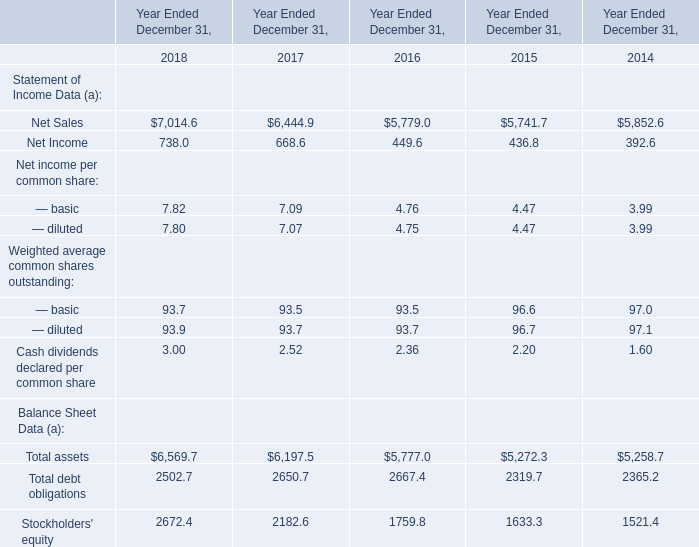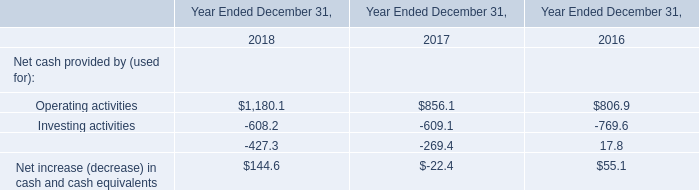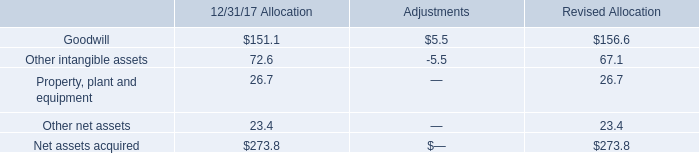What is the average value of Net Income in Table 0 and Operating activities in Table 1 in 2016? 
Computations: ((449.6 + 806.9) / 2)
Answer: 628.25. What is the sum of Net Sales and Net Income in 2018 ? 
Computations: (7014.6 + 738)
Answer: 7752.6. 